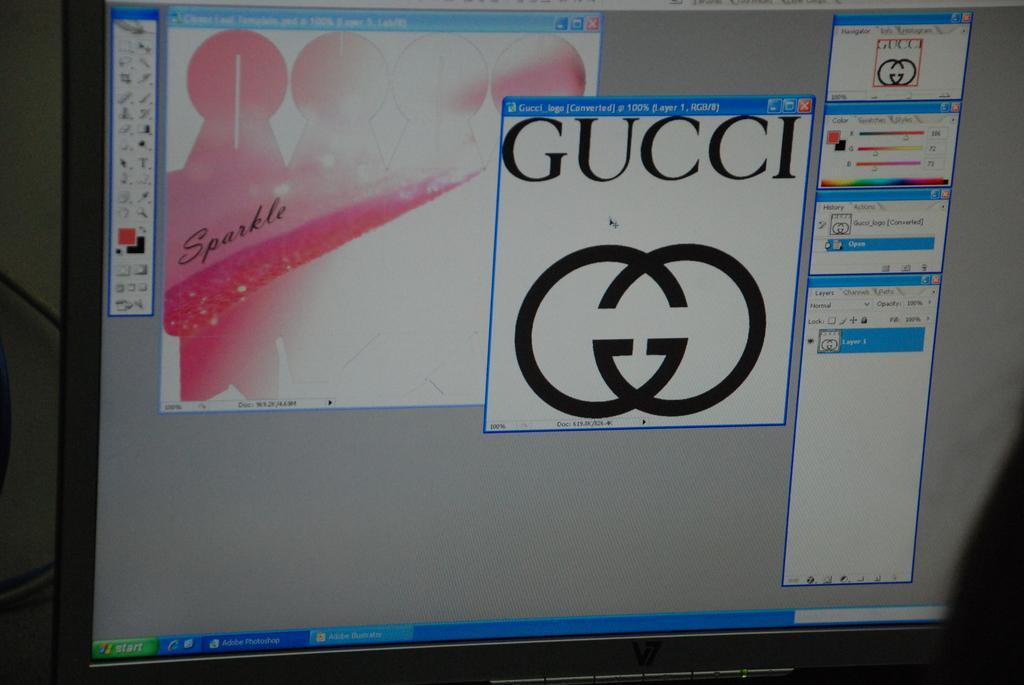Please provide a concise description of this image. In this picture I can see the monitor of the computer. 